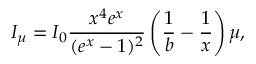Convert formula to latex. <formula><loc_0><loc_0><loc_500><loc_500>I _ { \mu } = I _ { 0 } \frac { x ^ { 4 } e ^ { x } } { ( e ^ { x } - 1 ) ^ { 2 } } \left ( \frac { 1 } { b } - \frac { 1 } { x } \right ) \mu ,</formula> 